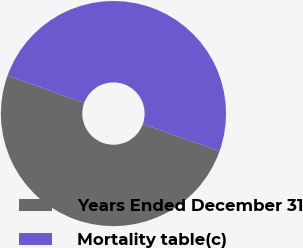Convert chart to OTSL. <chart><loc_0><loc_0><loc_500><loc_500><pie_chart><fcel>Years Ended December 31<fcel>Mortality table(c)<nl><fcel>50.06%<fcel>49.94%<nl></chart> 